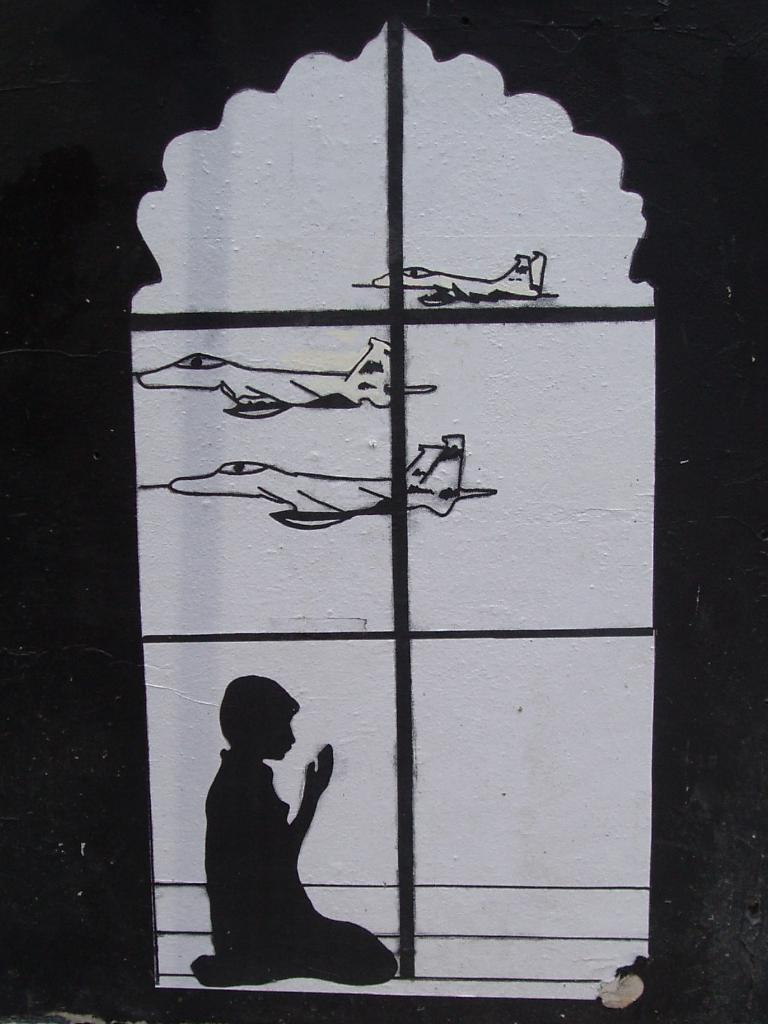What is the main subject of the image? The main subject of the image is a painting. Can you describe the painting's color scheme? The painting is white and black in color. What is depicted in the painting? The painting depicts a person sitting and aircrafts flying in the air. How many women are present in the painting? There are no women depicted in the painting; it features a person sitting and aircrafts flying in the air. Can you describe the snake in the painting? There is no snake present in the painting; it only depicts a person sitting and aircrafts flying in the air. 